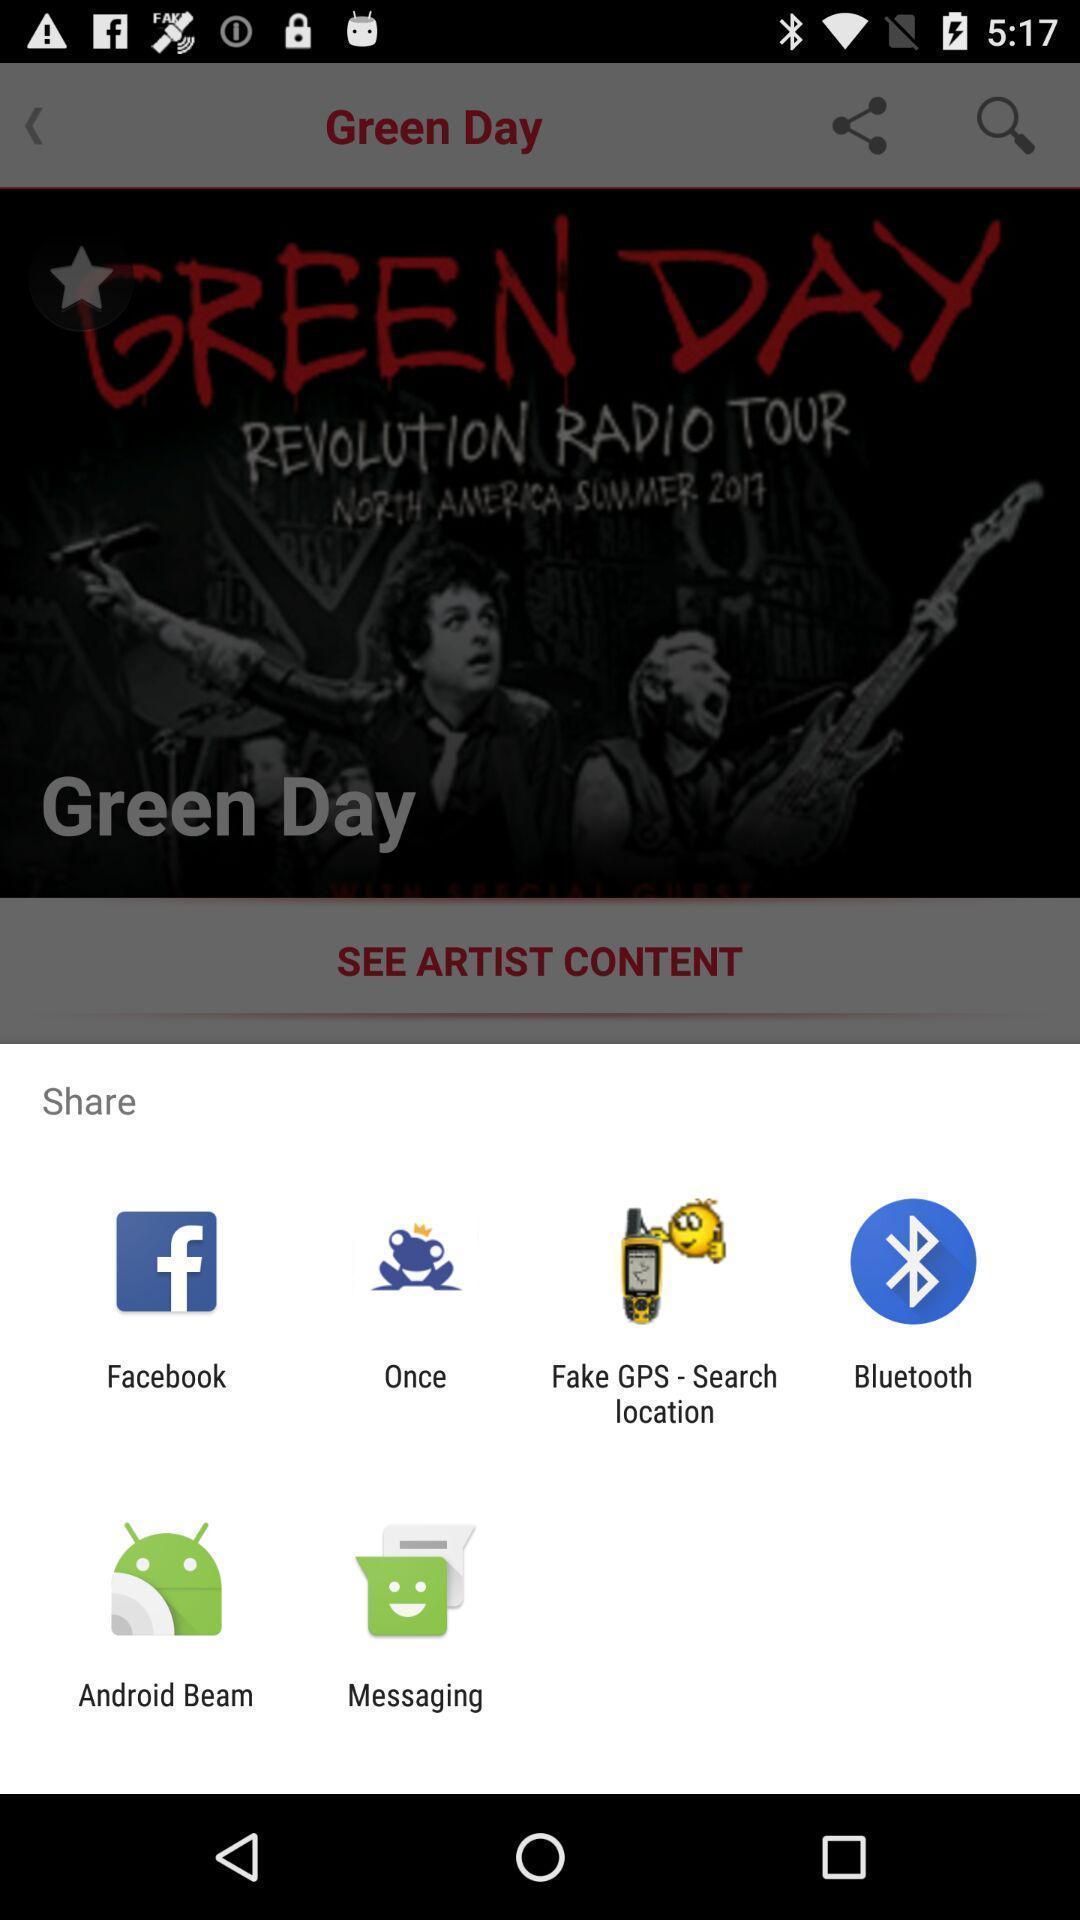Tell me what you see in this picture. Pop-up to share via different apps. 